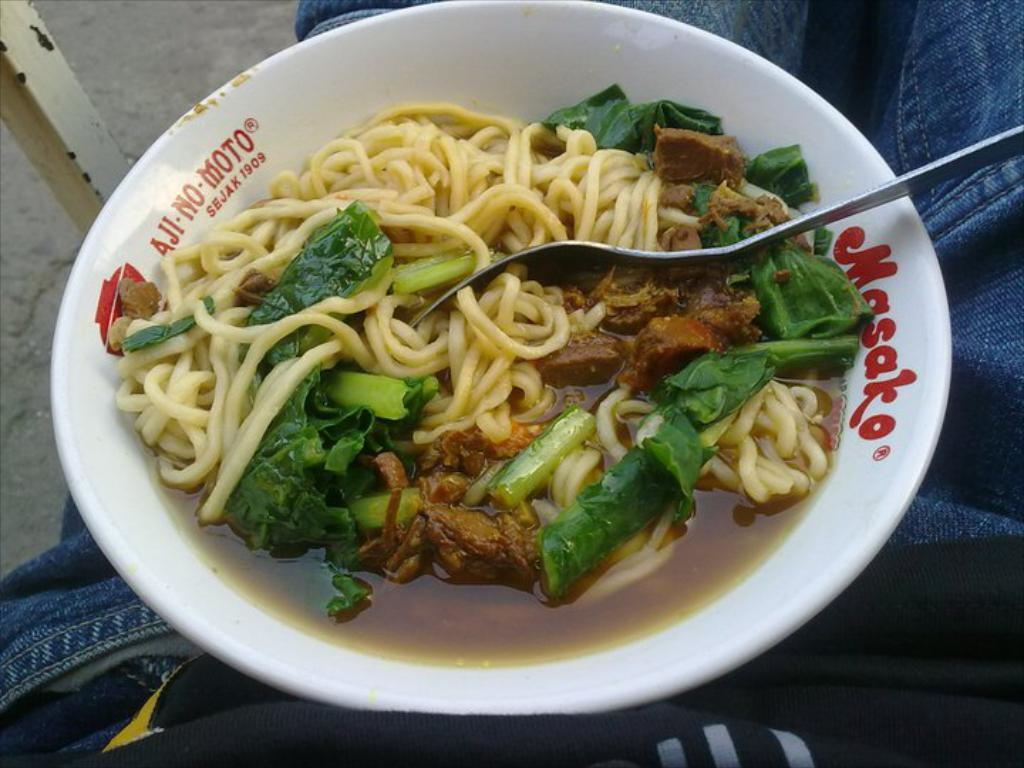What is the main subject of the image? There is an edible in the image. How is the edible presented in the image? The edible is placed in a white bowl. What utensil is placed with the edible? There is a fork placed in the edible. What type of design can be seen on the attempt to walk in the image? There is no attempt to walk or any design related to walking present in the image. 